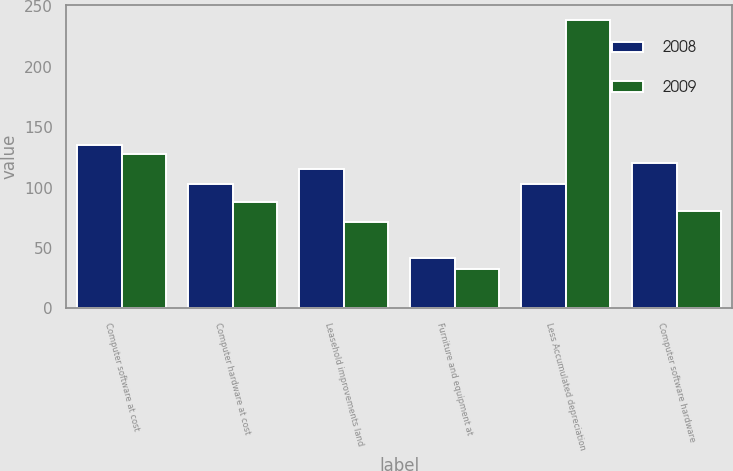Convert chart to OTSL. <chart><loc_0><loc_0><loc_500><loc_500><stacked_bar_chart><ecel><fcel>Computer software at cost<fcel>Computer hardware at cost<fcel>Leasehold improvements land<fcel>Furniture and equipment at<fcel>Less Accumulated depreciation<fcel>Computer software hardware<nl><fcel>2008<fcel>135<fcel>103.1<fcel>115<fcel>41.6<fcel>103.1<fcel>120.6<nl><fcel>2009<fcel>127.4<fcel>87.9<fcel>71.1<fcel>32.7<fcel>238.9<fcel>80.2<nl></chart> 